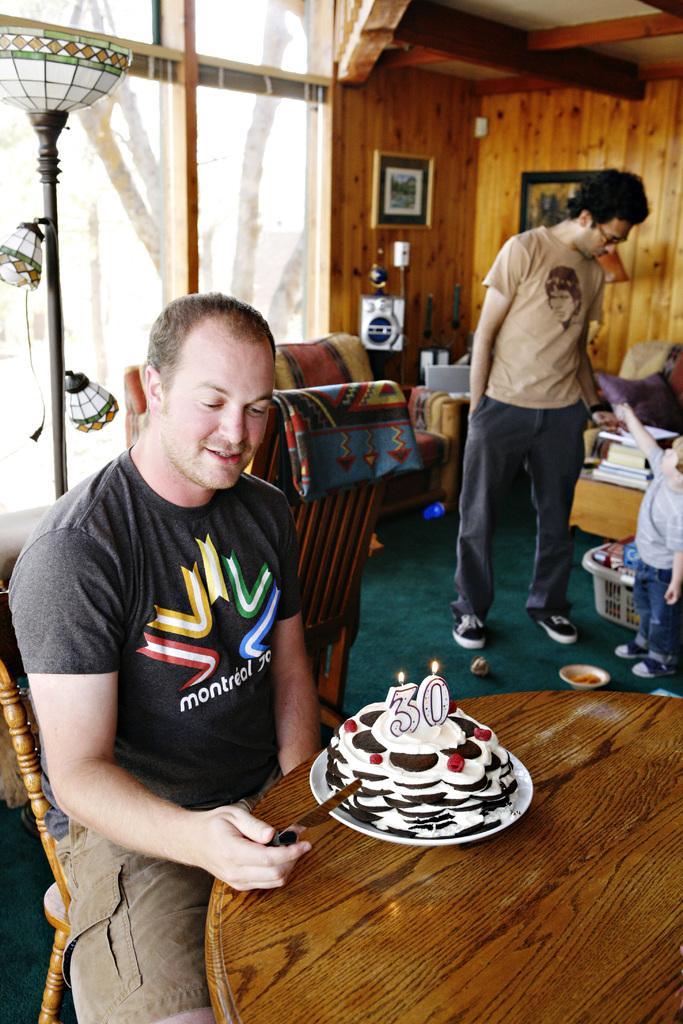Describe this image in one or two sentences. In this image I see a man who is sitting on the chair and he is smiling, I can also see that he is holding a knife, there is a table in front of him and there is a cake on it. In the background i see a man, a child, sofa, wall and photo frames on it and I can also see a window. 